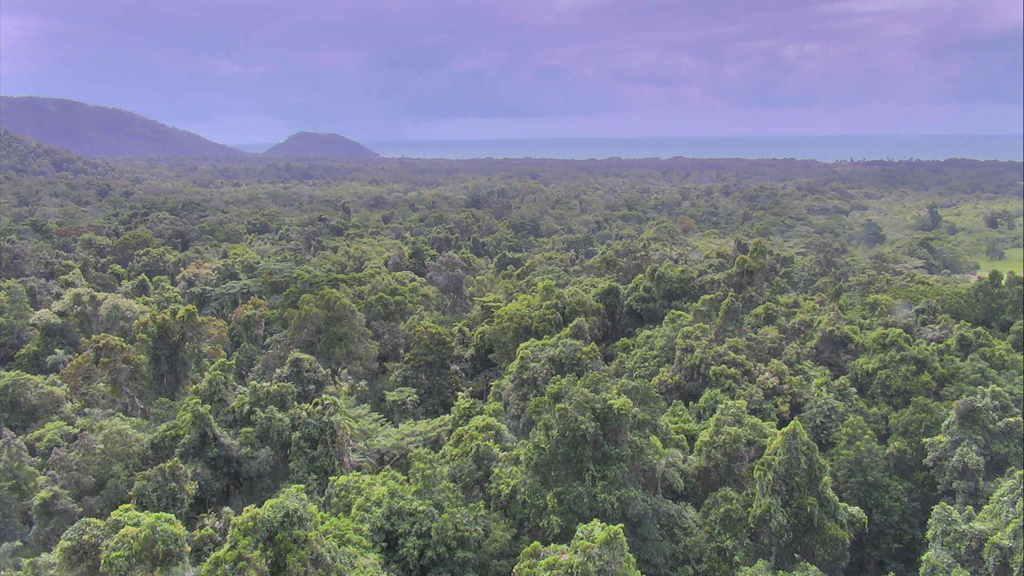Describe this image in one or two sentences. In this image we can see trees, in the background of the image there are mountains. 